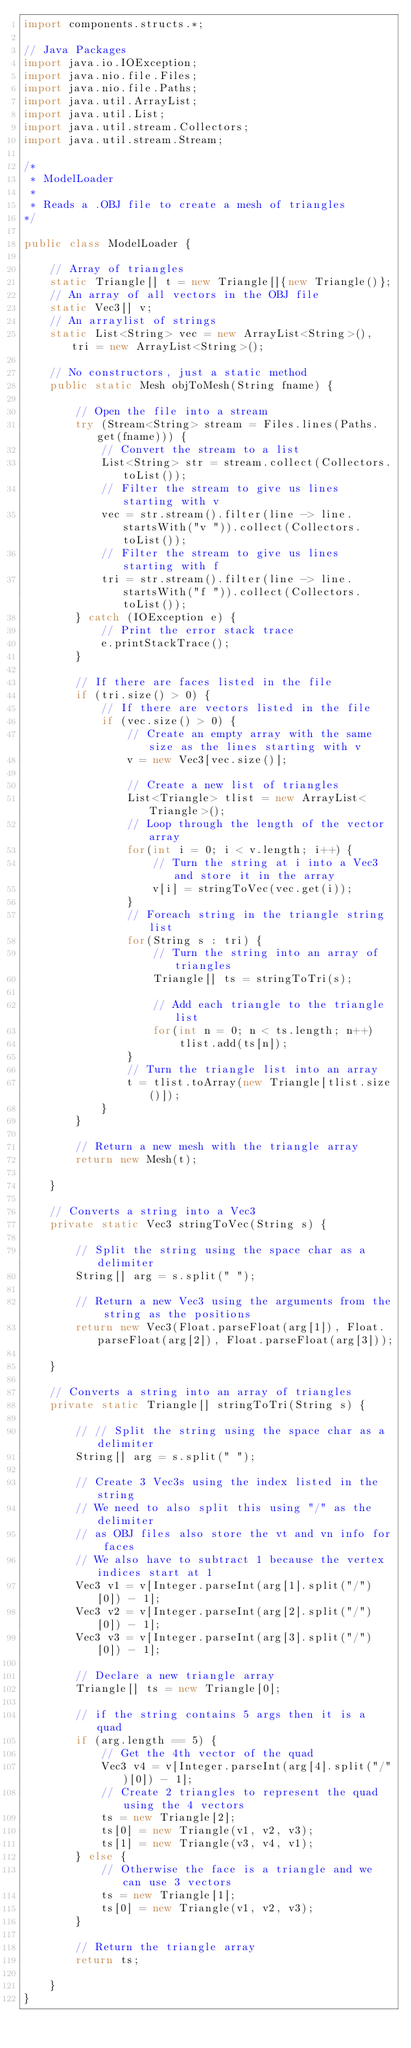Convert code to text. <code><loc_0><loc_0><loc_500><loc_500><_Java_>import components.structs.*;

// Java Packages
import java.io.IOException;
import java.nio.file.Files;
import java.nio.file.Paths;
import java.util.ArrayList;
import java.util.List;
import java.util.stream.Collectors;
import java.util.stream.Stream;

/*
 * ModelLoader
 * 
 * Reads a .OBJ file to create a mesh of triangles
*/

public class ModelLoader {
    
    // Array of triangles
    static Triangle[] t = new Triangle[]{new Triangle()};
    // An array of all vectors in the OBJ file
    static Vec3[] v;
    // An arraylist of strings
    static List<String> vec = new ArrayList<String>(), tri = new ArrayList<String>();

    // No constructors, just a static method
    public static Mesh objToMesh(String fname) {
        
        // Open the file into a stream
        try (Stream<String> stream = Files.lines(Paths.get(fname))) {
            // Convert the stream to a list
            List<String> str = stream.collect(Collectors.toList());
            // Filter the stream to give us lines starting with v
            vec = str.stream().filter(line -> line.startsWith("v ")).collect(Collectors.toList());
            // Filter the stream to give us lines starting with f
            tri = str.stream().filter(line -> line.startsWith("f ")).collect(Collectors.toList());
        } catch (IOException e) {
            // Print the error stack trace
            e.printStackTrace();
        }

        // If there are faces listed in the file
        if (tri.size() > 0) {
            // If there are vectors listed in the file
            if (vec.size() > 0) {
                // Create an empty array with the same size as the lines starting with v
                v = new Vec3[vec.size()];
                
                // Create a new list of triangles
                List<Triangle> tlist = new ArrayList<Triangle>();
                // Loop through the length of the vector array
                for(int i = 0; i < v.length; i++) {
                    // Turn the string at i into a Vec3 and store it in the array
                    v[i] = stringToVec(vec.get(i));
                }
                // Foreach string in the triangle string list
                for(String s : tri) {
                    // Turn the string into an array of triangles
                    Triangle[] ts = stringToTri(s);
                    
                    // Add each triangle to the triangle list
                    for(int n = 0; n < ts.length; n++)
                        tlist.add(ts[n]);
                }
                // Turn the triangle list into an array
                t = tlist.toArray(new Triangle[tlist.size()]);
            }
        }
        
        // Return a new mesh with the triangle array
        return new Mesh(t);
        
    }
    
    // Converts a string into a Vec3
    private static Vec3 stringToVec(String s) {
        
        // Split the string using the space char as a delimiter
        String[] arg = s.split(" ");
        
        // Return a new Vec3 using the arguments from the string as the positions
        return new Vec3(Float.parseFloat(arg[1]), Float.parseFloat(arg[2]), Float.parseFloat(arg[3]));
        
    }

    // Converts a string into an array of triangles
    private static Triangle[] stringToTri(String s) {
        
        // // Split the string using the space char as a delimiter
        String[] arg = s.split(" ");
        
        // Create 3 Vec3s using the index listed in the string
        // We need to also split this using "/" as the delimiter
        // as OBJ files also store the vt and vn info for faces
        // We also have to subtract 1 because the vertex indices start at 1
        Vec3 v1 = v[Integer.parseInt(arg[1].split("/")[0]) - 1];
        Vec3 v2 = v[Integer.parseInt(arg[2].split("/")[0]) - 1];
        Vec3 v3 = v[Integer.parseInt(arg[3].split("/")[0]) - 1];
        
        // Declare a new triangle array
        Triangle[] ts = new Triangle[0];
        
        // if the string contains 5 args then it is a quad
        if (arg.length == 5) {
            // Get the 4th vector of the quad
            Vec3 v4 = v[Integer.parseInt(arg[4].split("/")[0]) - 1];
            // Create 2 triangles to represent the quad using the 4 vectors
            ts = new Triangle[2];
            ts[0] = new Triangle(v1, v2, v3);
            ts[1] = new Triangle(v3, v4, v1);
        } else {
            // Otherwise the face is a triangle and we can use 3 vectors
            ts = new Triangle[1];
            ts[0] = new Triangle(v1, v2, v3);
        }
        
        // Return the triangle array
        return ts;
        
    }
}
</code> 